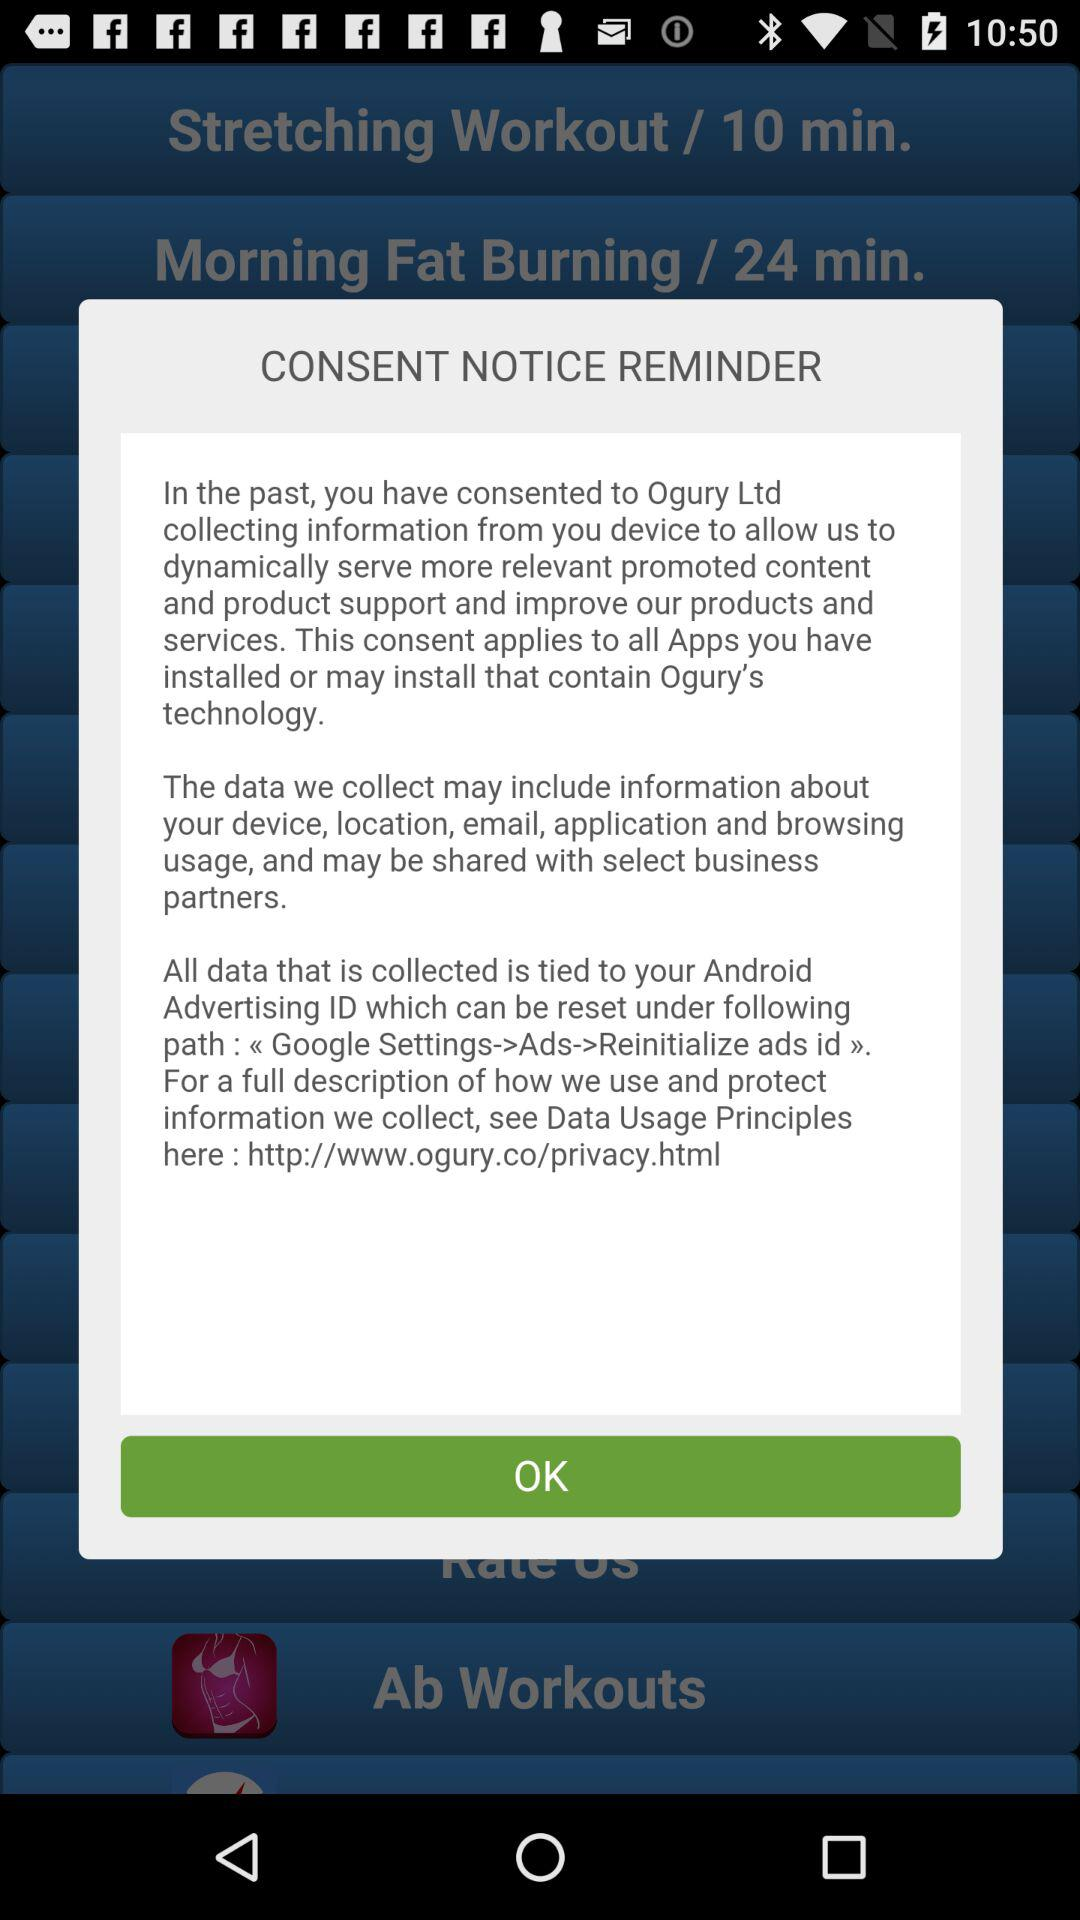What is the fat-burning workout time duration? The time duration is 24 minutes. 